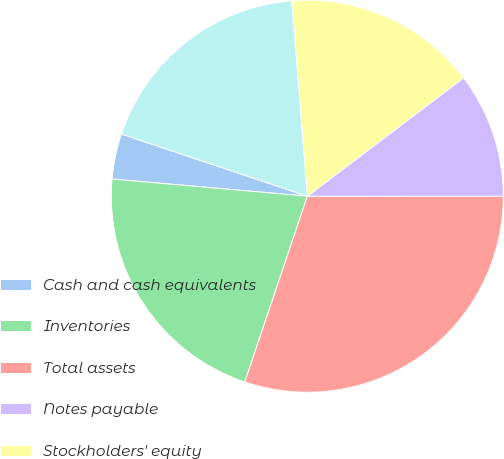Convert chart. <chart><loc_0><loc_0><loc_500><loc_500><pie_chart><fcel>Cash and cash equivalents<fcel>Inventories<fcel>Total assets<fcel>Notes payable<fcel>Stockholders' equity<fcel>Total equity<nl><fcel>3.74%<fcel>21.23%<fcel>30.17%<fcel>10.31%<fcel>15.95%<fcel>18.59%<nl></chart> 